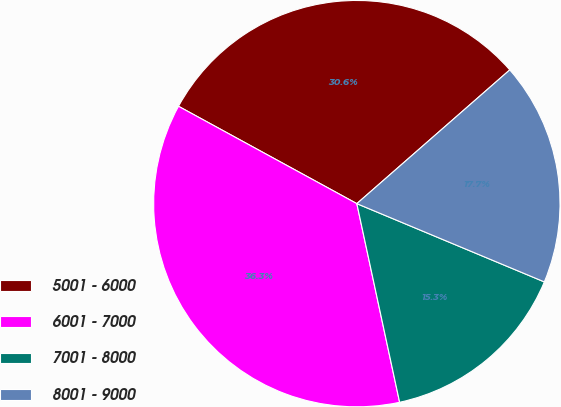Convert chart to OTSL. <chart><loc_0><loc_0><loc_500><loc_500><pie_chart><fcel>5001 - 6000<fcel>6001 - 7000<fcel>7001 - 8000<fcel>8001 - 9000<nl><fcel>30.61%<fcel>36.33%<fcel>15.33%<fcel>17.73%<nl></chart> 